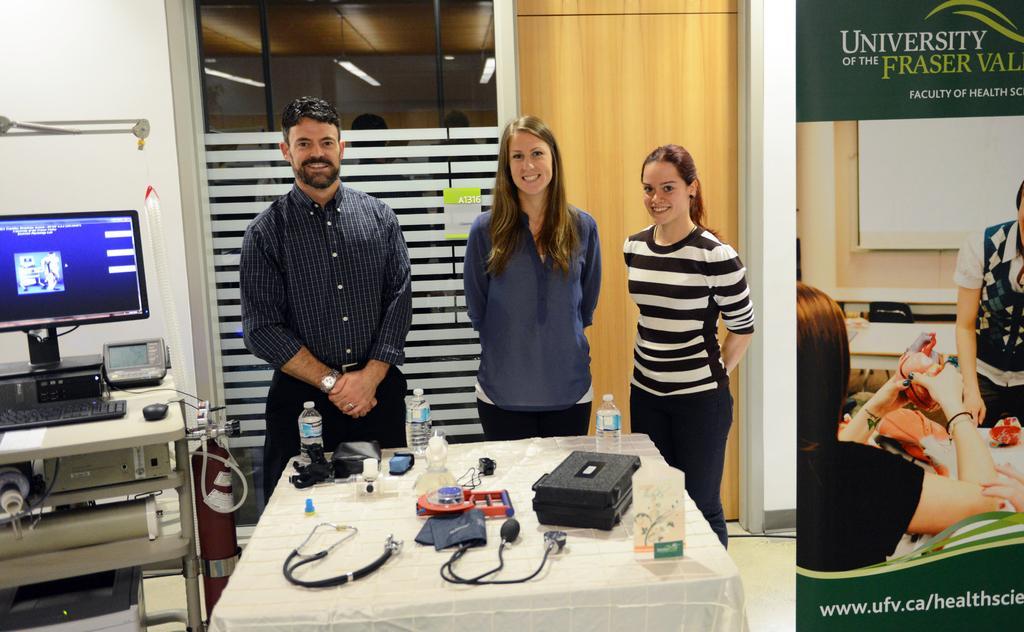How would you summarize this image in a sentence or two? In this image I can see three people with different color dresses. In-front of these people I can see the bottles, board, wires and many objects on the table. To the left I can see the system and an electronic device on the table. To the right I can see the banner. In the background I can see the door. 